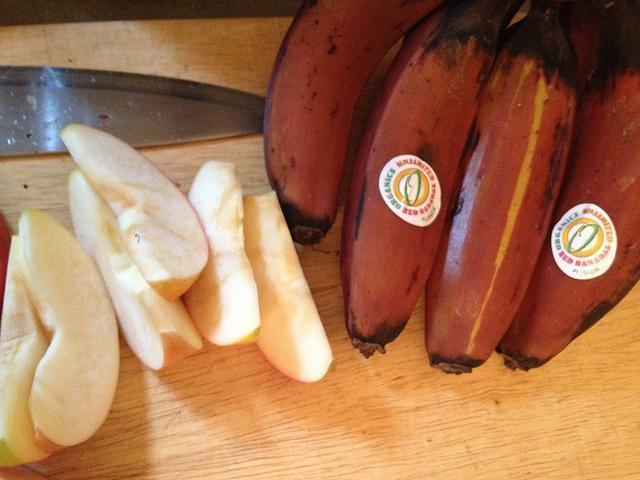How many apples are in the picture?
Give a very brief answer. 2. How many trains are there?
Give a very brief answer. 0. 